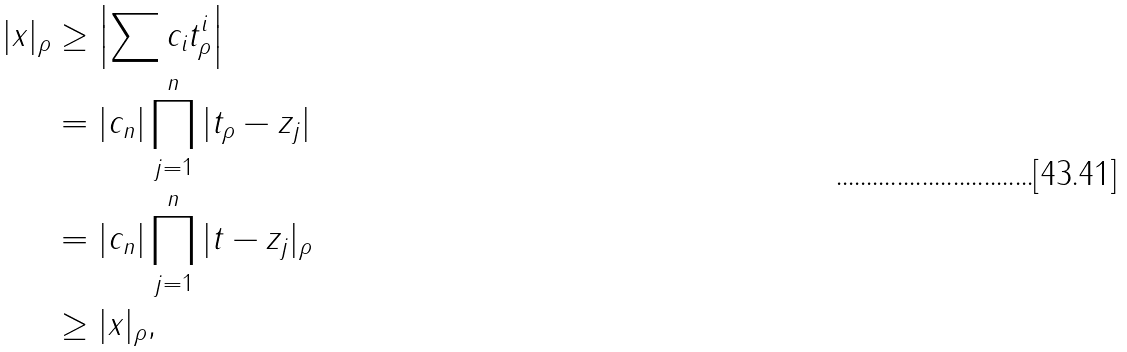Convert formula to latex. <formula><loc_0><loc_0><loc_500><loc_500>| x | _ { \rho } & \geq \left | \sum c _ { i } t _ { \rho } ^ { i } \right | \\ & = | c _ { n } | \prod _ { j = 1 } ^ { n } | t _ { \rho } - z _ { j } | \\ & = | c _ { n } | \prod _ { j = 1 } ^ { n } | t - z _ { j } | _ { \rho } \\ & \geq | x | _ { \rho } ,</formula> 